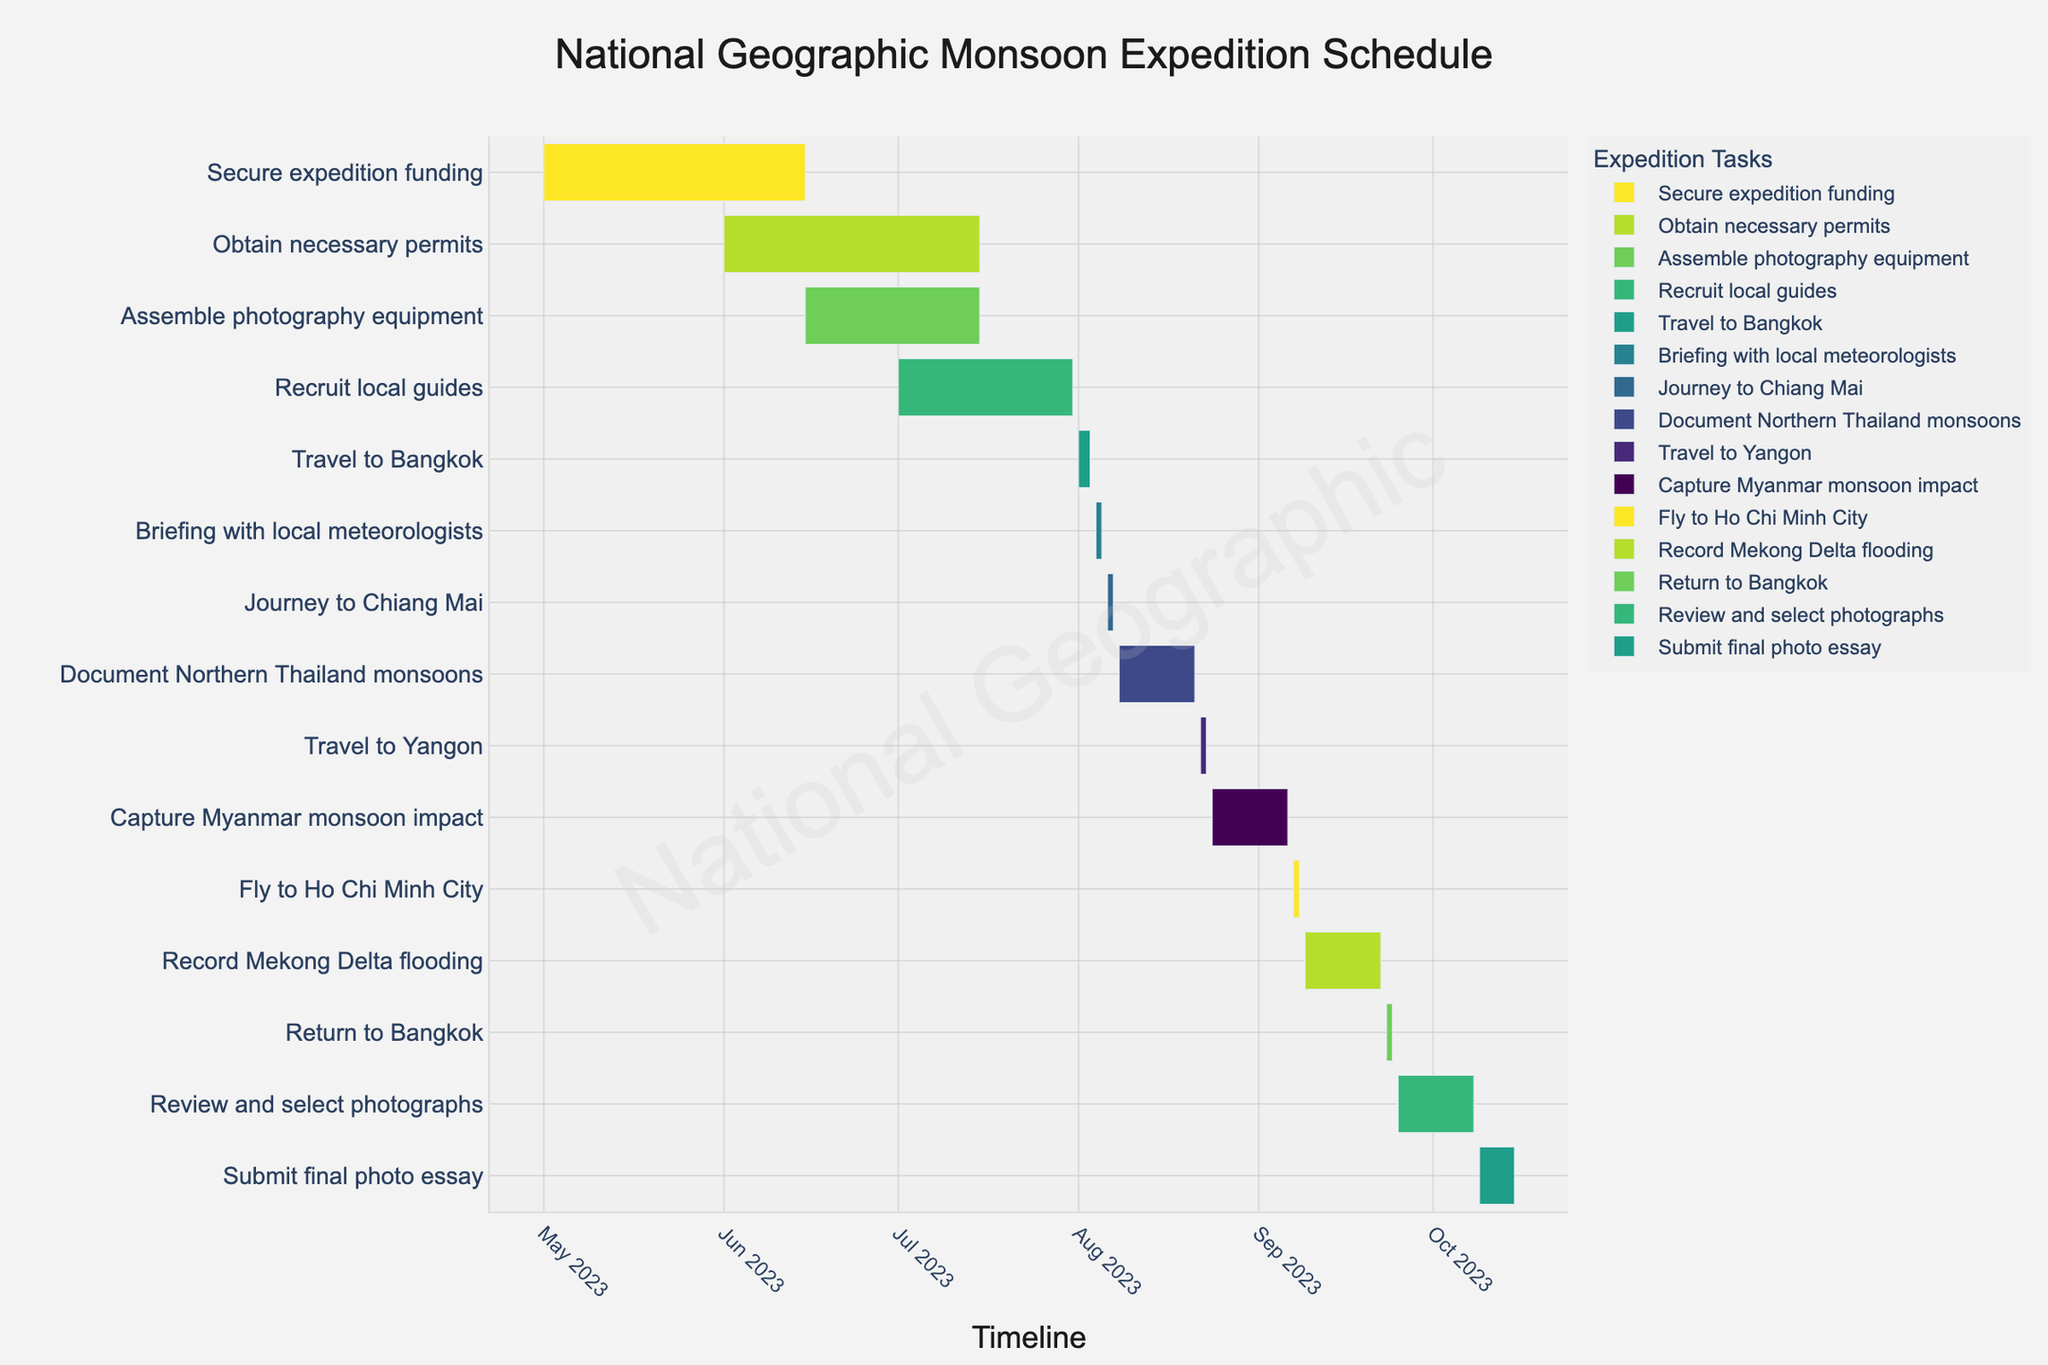Which task starts first in the expedition schedule? To determine which task starts first, look at the leftmost bar on the Gantt chart. The task corresponding to this bar is the first task.
Answer: Secure expedition funding Which task has the longest duration? Identify the task whose bar spans the greatest length along the timeline. Review the duration labels for confirmatory checks.
Answer: Secure expedition funding How many days will be spent traveling between locations during the expedition? Sum the durations of all tasks that involve travel: Travel to Bangkok (3 days), Journey to Chiang Mai (2 days), Travel to Yangon (2 days), Fly to Ho Chi Minh City (2 days), and Return to Bangkok (2 days). Calculating: 3+2+2+2+2 = 11 days
Answer: 11 days Does the "Submit final photo essay" task overlap with any other task? Locate the "Submit final photo essay" task on the timeline and compare its start and end dates to those of other tasks to see if there is any overlap.
Answer: No Which tasks have the same duration of 14 days? Identify the tasks whose bars span the same length, marked as 14 days on the timeline. These tasks are: Document Northern Thailand monsoons, Capture Myanmar monsoon impact, Record Mekong Delta flooding, and Review and select photographs.
Answer: Document Northern Thailand monsoons, Capture Myanmar monsoon impact, Record Mekong Delta flooding, Review and select photographs How long after the start date of "Secure expedition funding" does "Review and select photographs" begin? Find the start date of both tasks: "Secure expedition funding" starts on 2023-05-01, and "Review and select photographs" starts on 2023-09-25. Calculate the number of days between these dates using simple subtraction.
Answer: 147 days What is the color scheme used in the Gantt chart? Describe the visible color palette used for the bars in the Gantt chart. The chart uses a color scale known as Viridis, in reverse order.
Answer: Viridis color scale (reversed) What is the total duration of the expedition from the start of the first task to the end of the last task? Determine the duration by finding the difference between the start date of the first task and the end date of the final task. The first task starts on 2023-05-01 and the last task ends on 2023-10-15. Calculate the total number of days between these dates.
Answer: 168 days How many tasks are planned for August alone? Identify all tasks that have their start or end dates within the month of August. The tasks that fall into this period are Travel to Bangkok, Briefing with local meteorologists, Journey to Chiang Mai, Document Northern Thailand monsoons, Travel to Yangon, and Capture Myanmar monsoon impact.
Answer: 6 tasks 